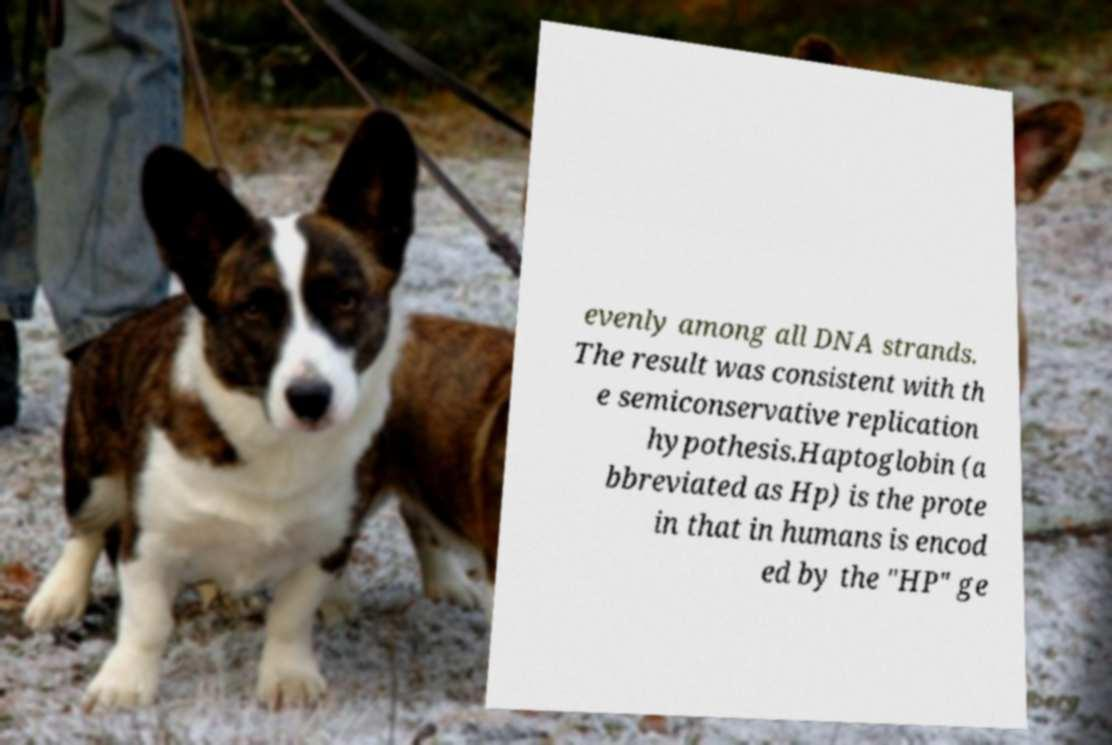Can you accurately transcribe the text from the provided image for me? evenly among all DNA strands. The result was consistent with th e semiconservative replication hypothesis.Haptoglobin (a bbreviated as Hp) is the prote in that in humans is encod ed by the "HP" ge 